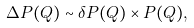Convert formula to latex. <formula><loc_0><loc_0><loc_500><loc_500>\Delta P ( Q ) \sim \delta P ( Q ) \times P ( Q ) ,</formula> 